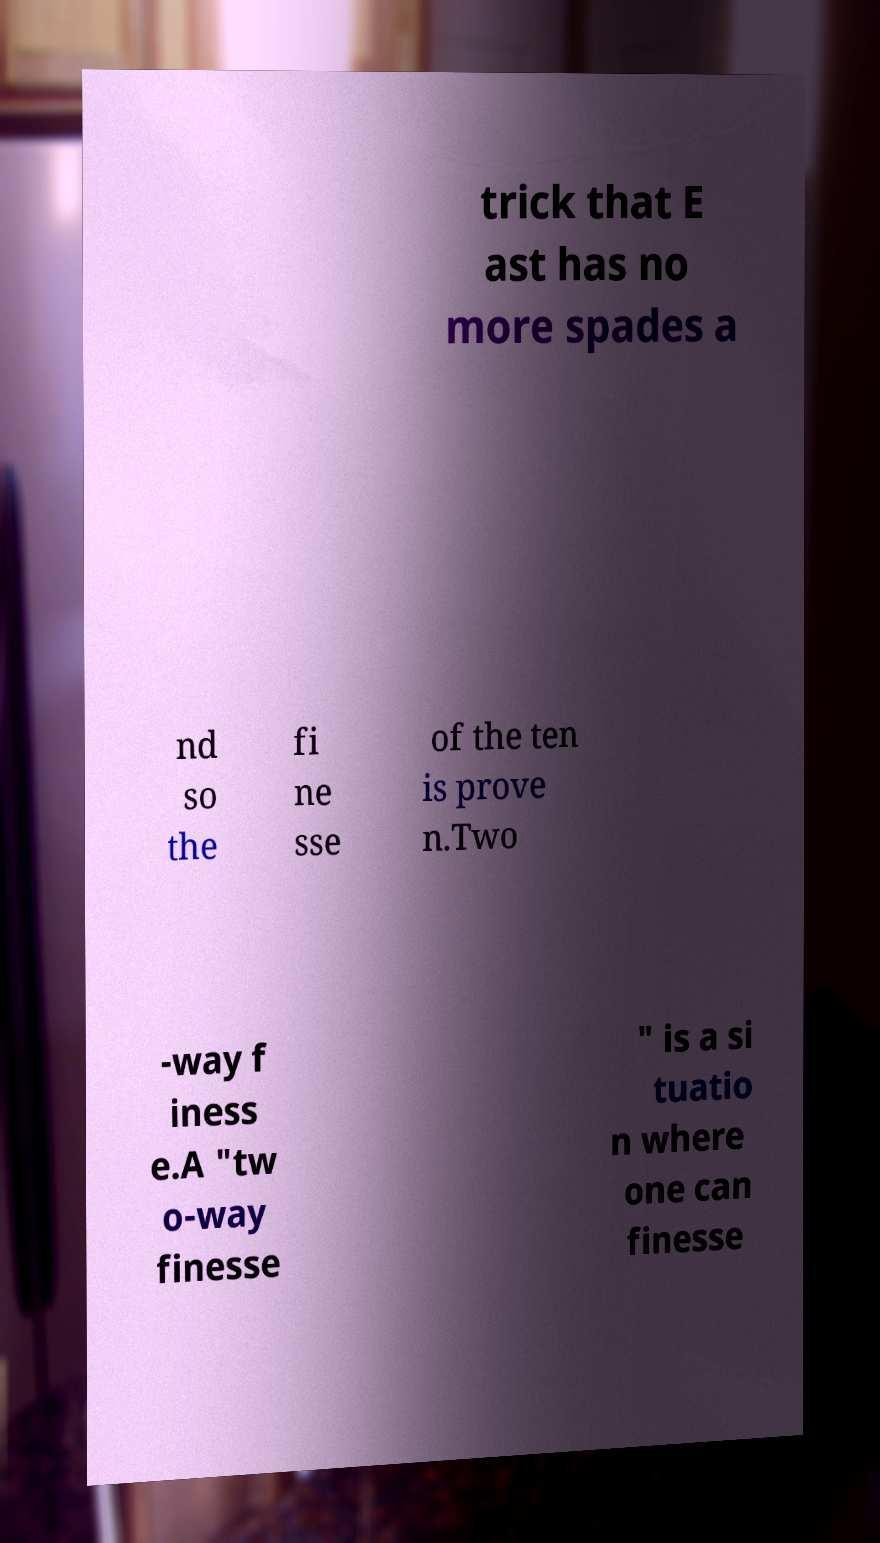Can you read and provide the text displayed in the image?This photo seems to have some interesting text. Can you extract and type it out for me? trick that E ast has no more spades a nd so the fi ne sse of the ten is prove n.Two -way f iness e.A "tw o-way finesse " is a si tuatio n where one can finesse 